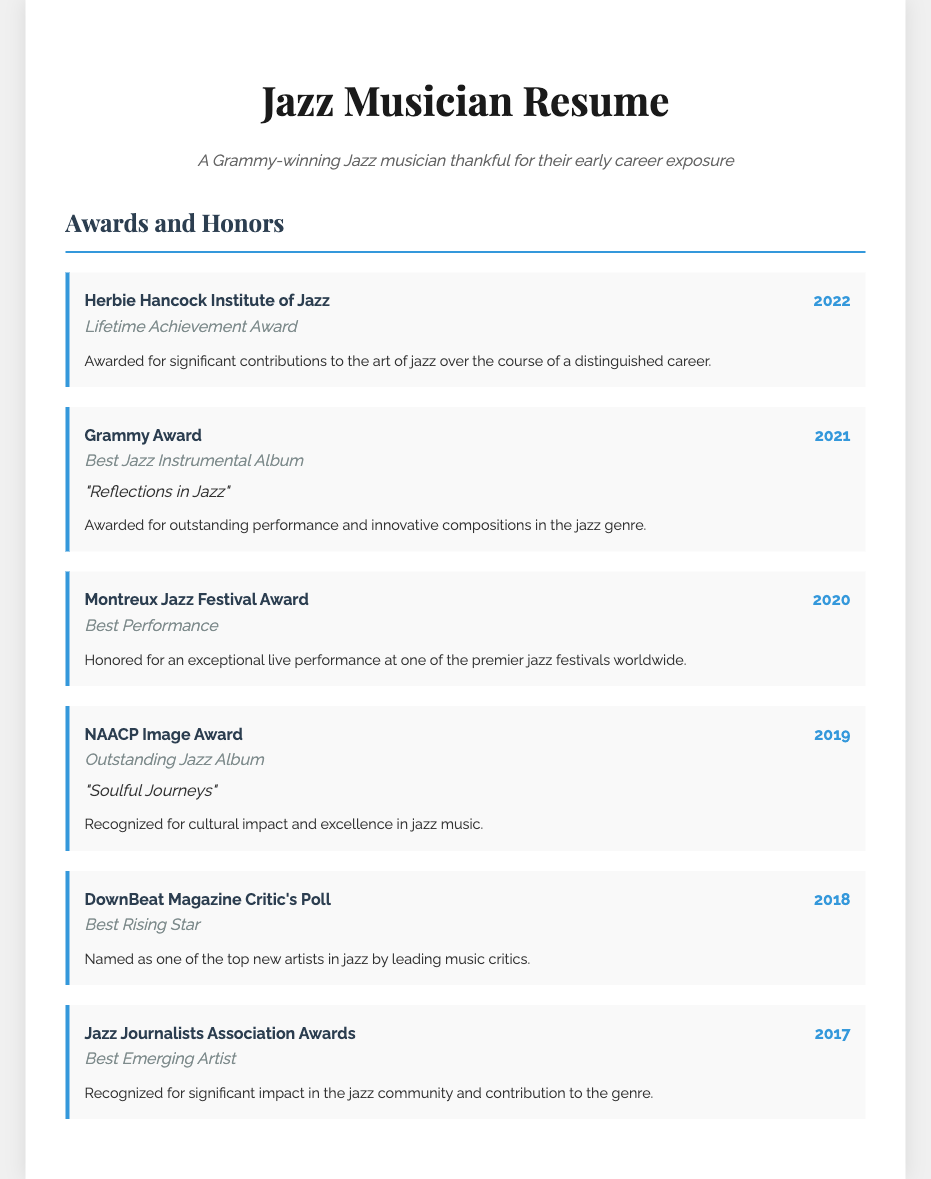What award did you receive in 2022? In 2022, the award received was the Lifetime Achievement Award from the Herbie Hancock Institute of Jazz.
Answer: Lifetime Achievement Award What was the title of the Grammy Award-winning album? The Grammy Award for Best Jazz Instrumental Album was awarded for the album "Reflections in Jazz".
Answer: "Reflections in Jazz" Which award did you win in 2020? In 2020, the award received was the Best Performance at the Montreux Jazz Festival.
Answer: Best Performance How many years are represented in the awards section? The awards section includes recognitions from 2017 to 2022, so there are six years.
Answer: 6 Which publication recognized you as Best Rising Star? DownBeat Magazine recognized the musician as Best Rising Star in 2018.
Answer: DownBeat Magazine What category was the 2019 NAACP Image Award for? The category for the 2019 NAACP Image Award was Outstanding Jazz Album.
Answer: Outstanding Jazz Album What significant recognition did you receive in 2017? In 2017, the recognition received was the Best Emerging Artist from the Jazz Journalists Association Awards.
Answer: Best Emerging Artist Which award honored you for an exceptional live performance? The Montreux Jazz Festival Award honored the musician for an exceptional live performance in 2020.
Answer: Montreux Jazz Festival Award 